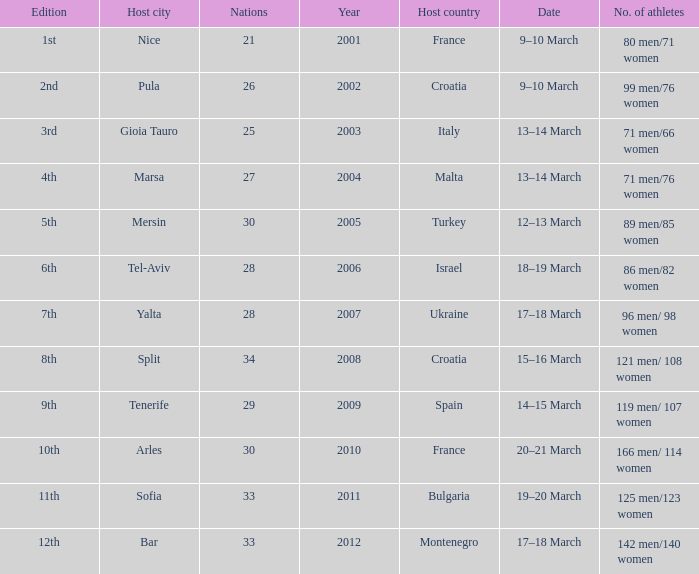In what year was Montenegro the host country? 2012.0. 